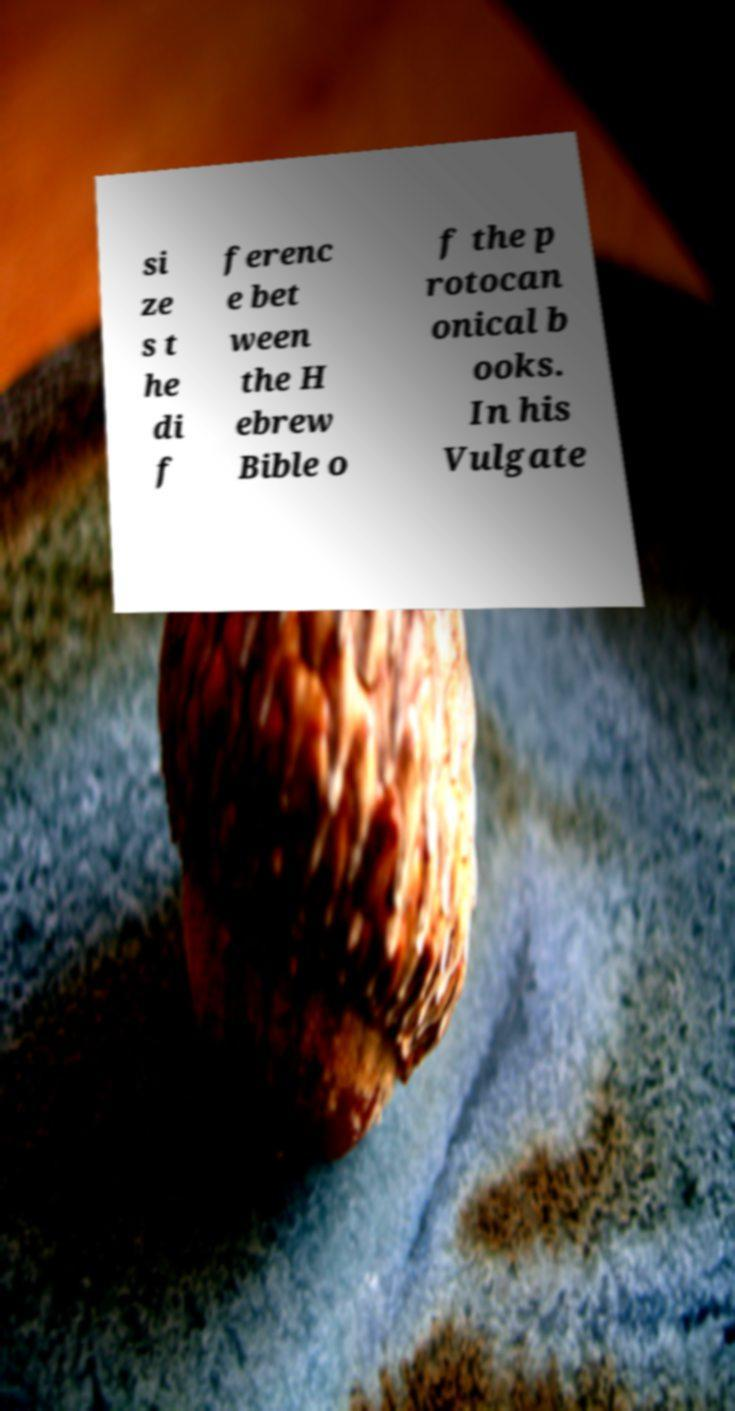I need the written content from this picture converted into text. Can you do that? si ze s t he di f ferenc e bet ween the H ebrew Bible o f the p rotocan onical b ooks. In his Vulgate 